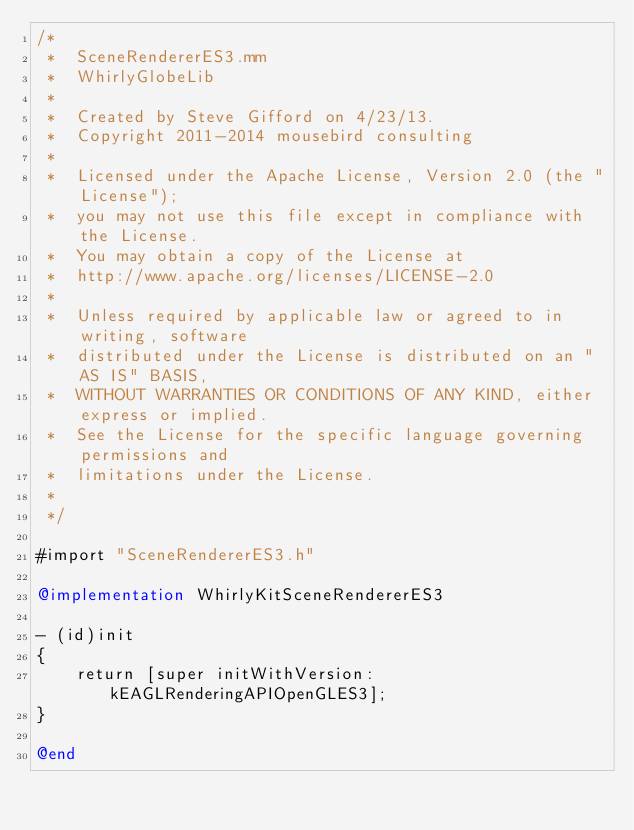<code> <loc_0><loc_0><loc_500><loc_500><_ObjectiveC_>/*
 *  SceneRendererES3.mm
 *  WhirlyGlobeLib
 *
 *  Created by Steve Gifford on 4/23/13.
 *  Copyright 2011-2014 mousebird consulting
 *
 *  Licensed under the Apache License, Version 2.0 (the "License");
 *  you may not use this file except in compliance with the License.
 *  You may obtain a copy of the License at
 *  http://www.apache.org/licenses/LICENSE-2.0
 *
 *  Unless required by applicable law or agreed to in writing, software
 *  distributed under the License is distributed on an "AS IS" BASIS,
 *  WITHOUT WARRANTIES OR CONDITIONS OF ANY KIND, either express or implied.
 *  See the License for the specific language governing permissions and
 *  limitations under the License.
 *
 */

#import "SceneRendererES3.h"

@implementation WhirlyKitSceneRendererES3

- (id)init
{
    return [super initWithVersion:kEAGLRenderingAPIOpenGLES3];
}

@end
</code> 